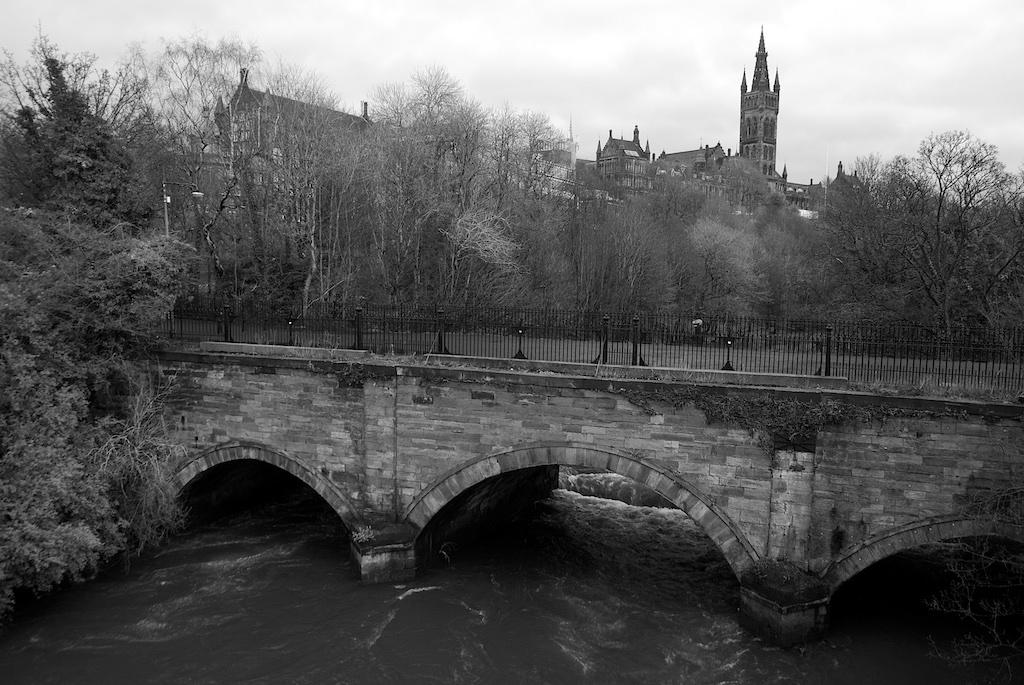What structure is present in the image? There is a bridge in the image. What is happening under the bridge? Water is flowing under the bridge. What is the color scheme of the image? The image is in black and white. What can be seen in the background of the image? There are trees, buildings, and clouds visible in the background of the image. What type of popcorn can be seen being sold near the bridge in the image? There is no popcorn present in the image; it is a black and white image of a bridge with water flowing under it and trees, buildings, and clouds in the background. 